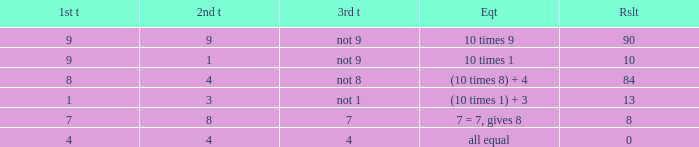What is the result when the 3rd throw is not 8? 84.0. 